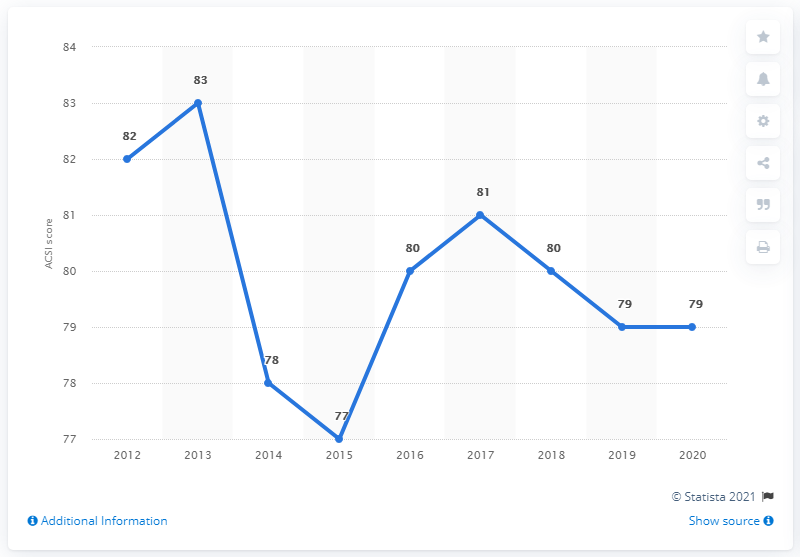Give some essential details in this illustration. Subway's ACSI score in 2020 was 79, indicating a generally positive customer satisfaction level. 